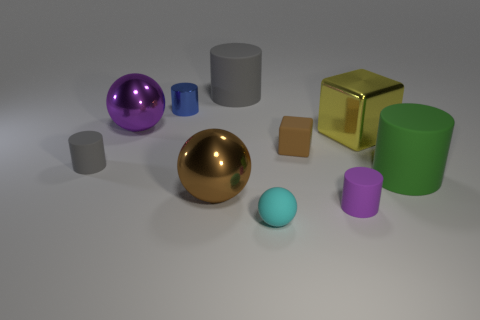What is the overall composition of the objects in terms of shapes and colors? The composition includes a variety of geometric shapes such as spheres, cubes, and cylinders, rendered in an array of colors including gold, purple, silver, and teal. The arrangement and diversity in shape and color create an interesting visual balance. Can you comment on the lighting and shadows in the scene? Certainly! The image features soft, diffused lighting that casts gentle shadows to the right of the objects, suggesting a light source to the left out of view. These shadows add depth to the scene, enhancing the perception of the objects' three-dimensionality. 